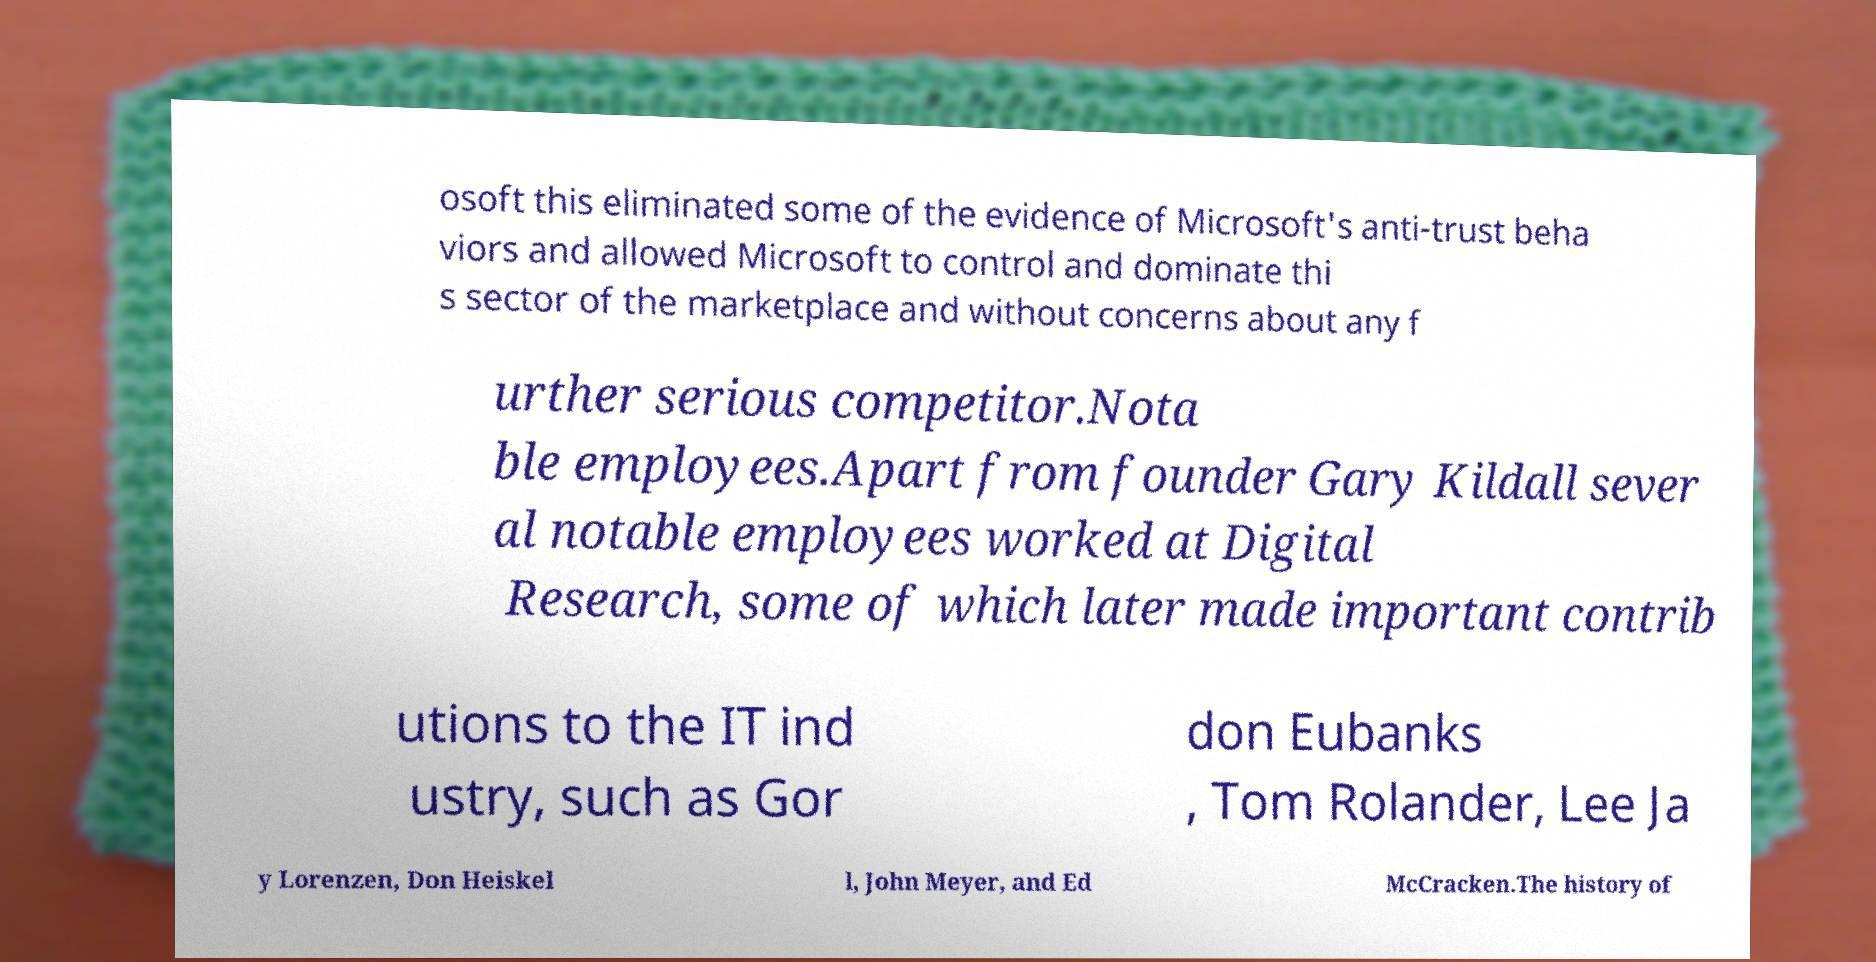There's text embedded in this image that I need extracted. Can you transcribe it verbatim? osoft this eliminated some of the evidence of Microsoft's anti-trust beha viors and allowed Microsoft to control and dominate thi s sector of the marketplace and without concerns about any f urther serious competitor.Nota ble employees.Apart from founder Gary Kildall sever al notable employees worked at Digital Research, some of which later made important contrib utions to the IT ind ustry, such as Gor don Eubanks , Tom Rolander, Lee Ja y Lorenzen, Don Heiskel l, John Meyer, and Ed McCracken.The history of 